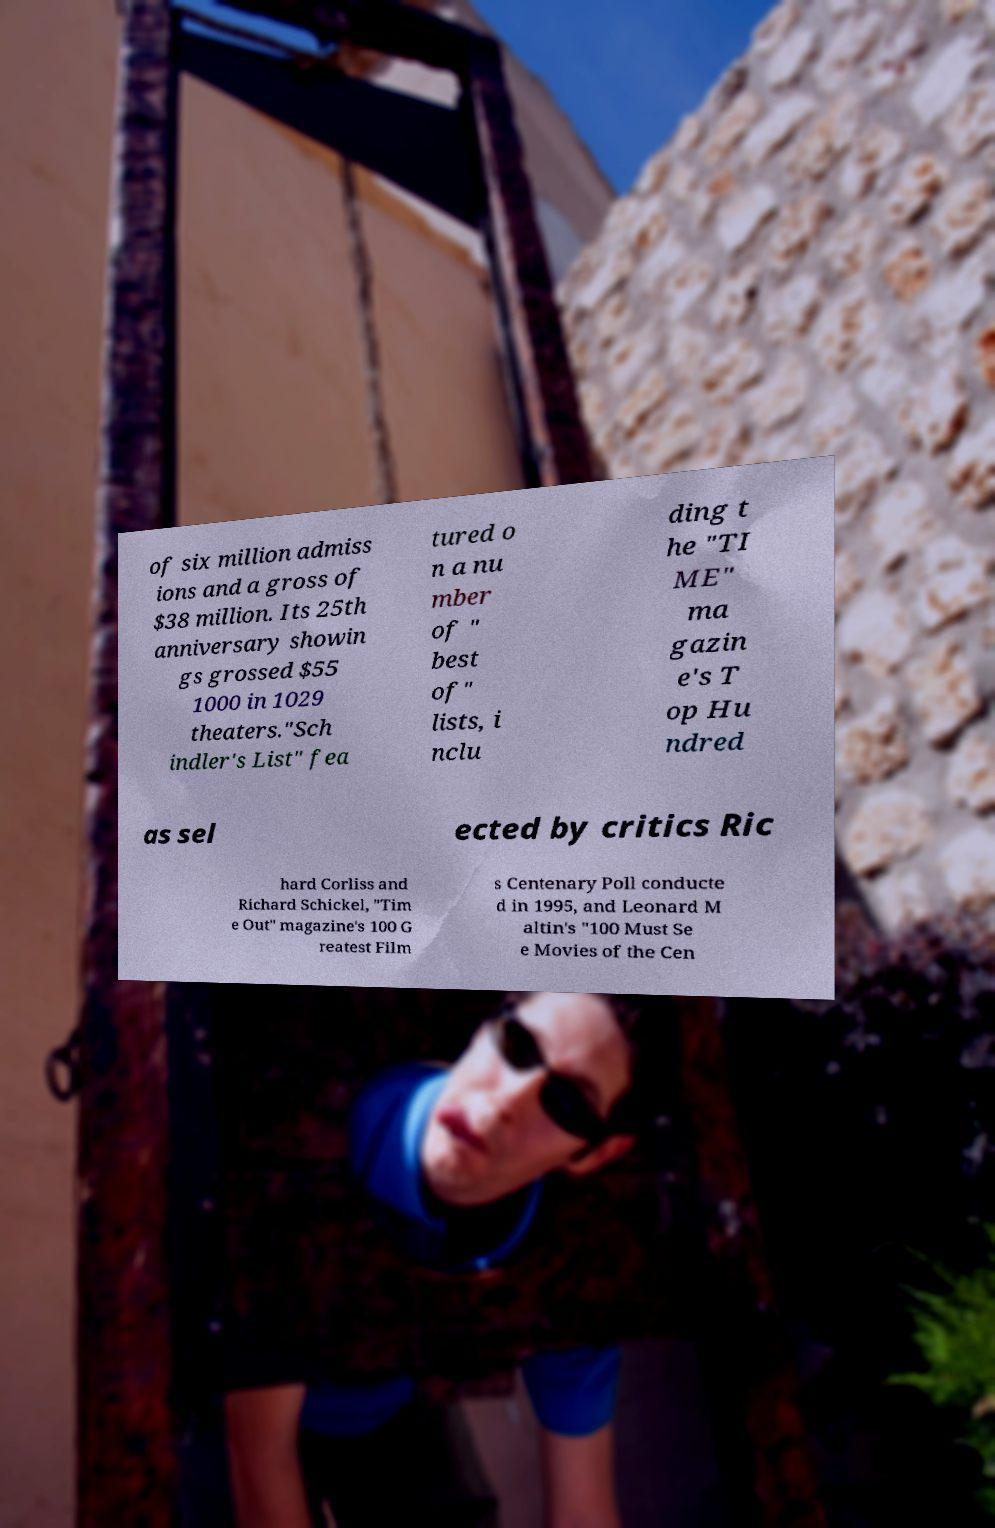I need the written content from this picture converted into text. Can you do that? of six million admiss ions and a gross of $38 million. Its 25th anniversary showin gs grossed $55 1000 in 1029 theaters."Sch indler's List" fea tured o n a nu mber of " best of" lists, i nclu ding t he "TI ME" ma gazin e's T op Hu ndred as sel ected by critics Ric hard Corliss and Richard Schickel, "Tim e Out" magazine's 100 G reatest Film s Centenary Poll conducte d in 1995, and Leonard M altin's "100 Must Se e Movies of the Cen 